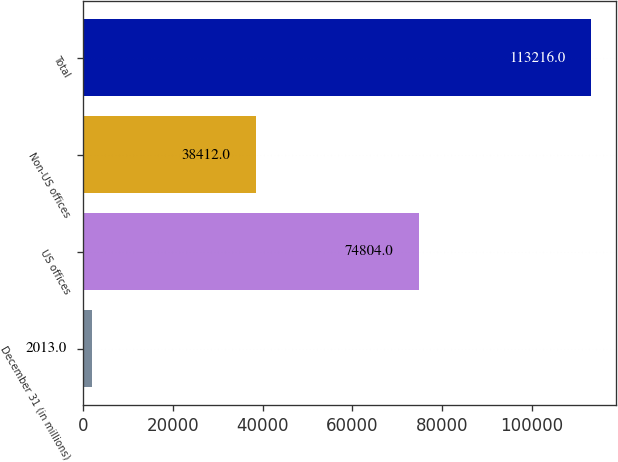Convert chart to OTSL. <chart><loc_0><loc_0><loc_500><loc_500><bar_chart><fcel>December 31 (in millions)<fcel>US offices<fcel>Non-US offices<fcel>Total<nl><fcel>2013<fcel>74804<fcel>38412<fcel>113216<nl></chart> 